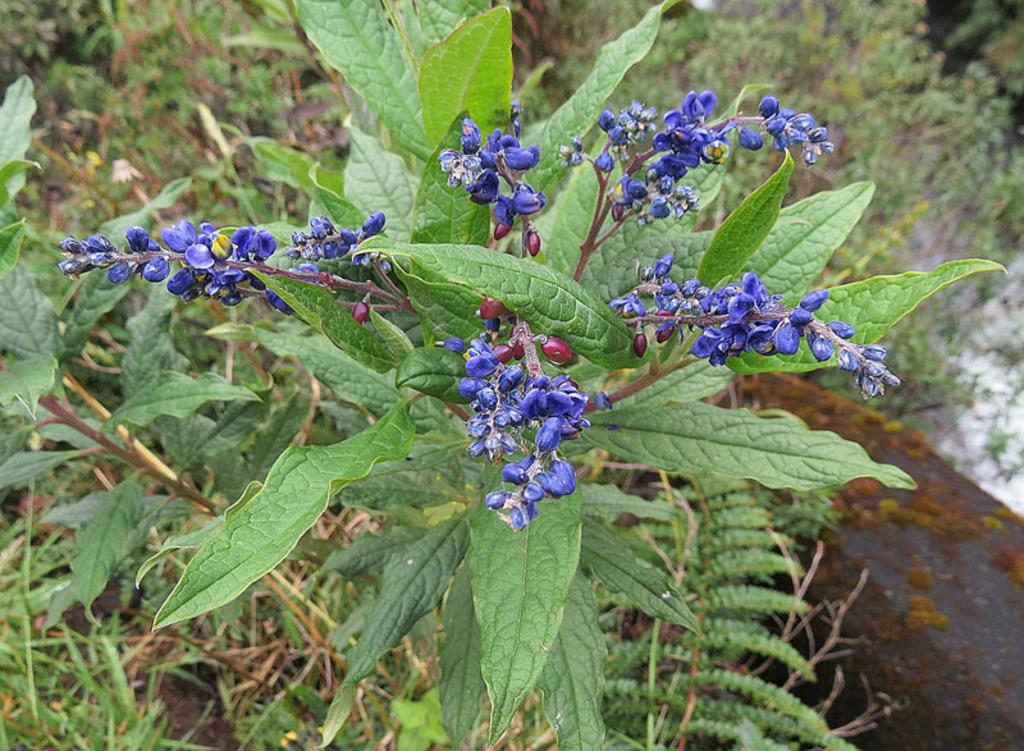What is the main subject in the center of the image? There is a plant with flowers and buds in the center of the image. What can be seen in the background of the image? There are plants and grass visible in the background of the image. Are there any other objects in the background of the image? Yes, there are other objects in the background of the image. What type of trouble is the ghost causing in the image? There is no ghost present in the image, so it is not possible to determine if any trouble is being caused. 